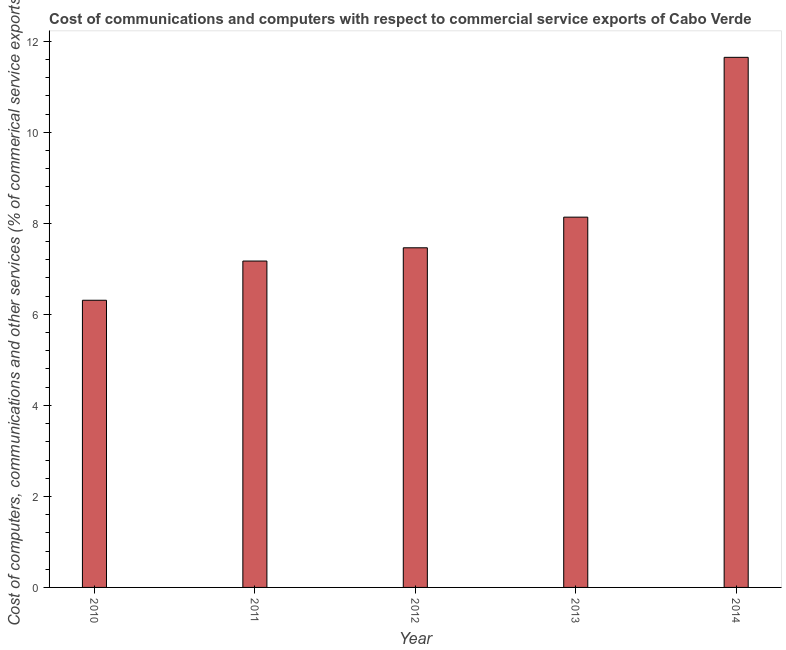What is the title of the graph?
Offer a terse response. Cost of communications and computers with respect to commercial service exports of Cabo Verde. What is the label or title of the Y-axis?
Ensure brevity in your answer.  Cost of computers, communications and other services (% of commerical service exports). What is the  computer and other services in 2011?
Your answer should be very brief. 7.17. Across all years, what is the maximum cost of communications?
Ensure brevity in your answer.  11.65. Across all years, what is the minimum cost of communications?
Keep it short and to the point. 6.31. In which year was the  computer and other services minimum?
Your response must be concise. 2010. What is the sum of the  computer and other services?
Provide a short and direct response. 40.73. What is the difference between the  computer and other services in 2011 and 2013?
Ensure brevity in your answer.  -0.96. What is the average cost of communications per year?
Your answer should be compact. 8.15. What is the median cost of communications?
Your answer should be very brief. 7.46. Do a majority of the years between 2011 and 2013 (inclusive) have cost of communications greater than 7.6 %?
Your answer should be very brief. No. What is the ratio of the  computer and other services in 2011 to that in 2013?
Your answer should be very brief. 0.88. Is the difference between the  computer and other services in 2011 and 2014 greater than the difference between any two years?
Your answer should be very brief. No. What is the difference between the highest and the second highest  computer and other services?
Provide a succinct answer. 3.51. Is the sum of the cost of communications in 2010 and 2011 greater than the maximum cost of communications across all years?
Give a very brief answer. Yes. What is the difference between the highest and the lowest cost of communications?
Ensure brevity in your answer.  5.34. How many bars are there?
Your answer should be compact. 5. Are the values on the major ticks of Y-axis written in scientific E-notation?
Provide a short and direct response. No. What is the Cost of computers, communications and other services (% of commerical service exports) of 2010?
Make the answer very short. 6.31. What is the Cost of computers, communications and other services (% of commerical service exports) of 2011?
Provide a short and direct response. 7.17. What is the Cost of computers, communications and other services (% of commerical service exports) in 2012?
Your answer should be compact. 7.46. What is the Cost of computers, communications and other services (% of commerical service exports) in 2013?
Keep it short and to the point. 8.14. What is the Cost of computers, communications and other services (% of commerical service exports) of 2014?
Give a very brief answer. 11.65. What is the difference between the Cost of computers, communications and other services (% of commerical service exports) in 2010 and 2011?
Make the answer very short. -0.86. What is the difference between the Cost of computers, communications and other services (% of commerical service exports) in 2010 and 2012?
Your answer should be very brief. -1.15. What is the difference between the Cost of computers, communications and other services (% of commerical service exports) in 2010 and 2013?
Ensure brevity in your answer.  -1.83. What is the difference between the Cost of computers, communications and other services (% of commerical service exports) in 2010 and 2014?
Give a very brief answer. -5.34. What is the difference between the Cost of computers, communications and other services (% of commerical service exports) in 2011 and 2012?
Offer a very short reply. -0.29. What is the difference between the Cost of computers, communications and other services (% of commerical service exports) in 2011 and 2013?
Your response must be concise. -0.96. What is the difference between the Cost of computers, communications and other services (% of commerical service exports) in 2011 and 2014?
Give a very brief answer. -4.48. What is the difference between the Cost of computers, communications and other services (% of commerical service exports) in 2012 and 2013?
Ensure brevity in your answer.  -0.67. What is the difference between the Cost of computers, communications and other services (% of commerical service exports) in 2012 and 2014?
Your answer should be compact. -4.19. What is the difference between the Cost of computers, communications and other services (% of commerical service exports) in 2013 and 2014?
Ensure brevity in your answer.  -3.51. What is the ratio of the Cost of computers, communications and other services (% of commerical service exports) in 2010 to that in 2012?
Ensure brevity in your answer.  0.85. What is the ratio of the Cost of computers, communications and other services (% of commerical service exports) in 2010 to that in 2013?
Provide a short and direct response. 0.78. What is the ratio of the Cost of computers, communications and other services (% of commerical service exports) in 2010 to that in 2014?
Give a very brief answer. 0.54. What is the ratio of the Cost of computers, communications and other services (% of commerical service exports) in 2011 to that in 2013?
Make the answer very short. 0.88. What is the ratio of the Cost of computers, communications and other services (% of commerical service exports) in 2011 to that in 2014?
Give a very brief answer. 0.62. What is the ratio of the Cost of computers, communications and other services (% of commerical service exports) in 2012 to that in 2013?
Offer a very short reply. 0.92. What is the ratio of the Cost of computers, communications and other services (% of commerical service exports) in 2012 to that in 2014?
Provide a short and direct response. 0.64. What is the ratio of the Cost of computers, communications and other services (% of commerical service exports) in 2013 to that in 2014?
Ensure brevity in your answer.  0.7. 